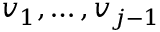<formula> <loc_0><loc_0><loc_500><loc_500>v _ { 1 } , \dots , v _ { j - 1 }</formula> 